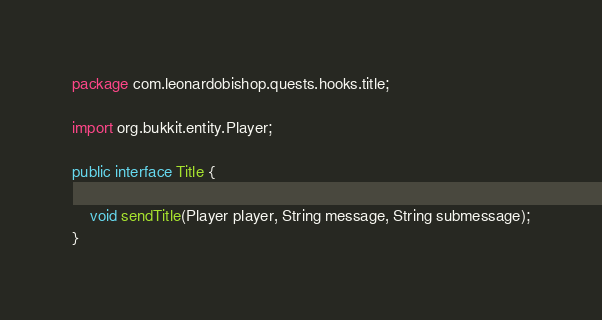Convert code to text. <code><loc_0><loc_0><loc_500><loc_500><_Java_>package com.leonardobishop.quests.hooks.title;

import org.bukkit.entity.Player;

public interface Title {

    void sendTitle(Player player, String message, String submessage);
}</code> 